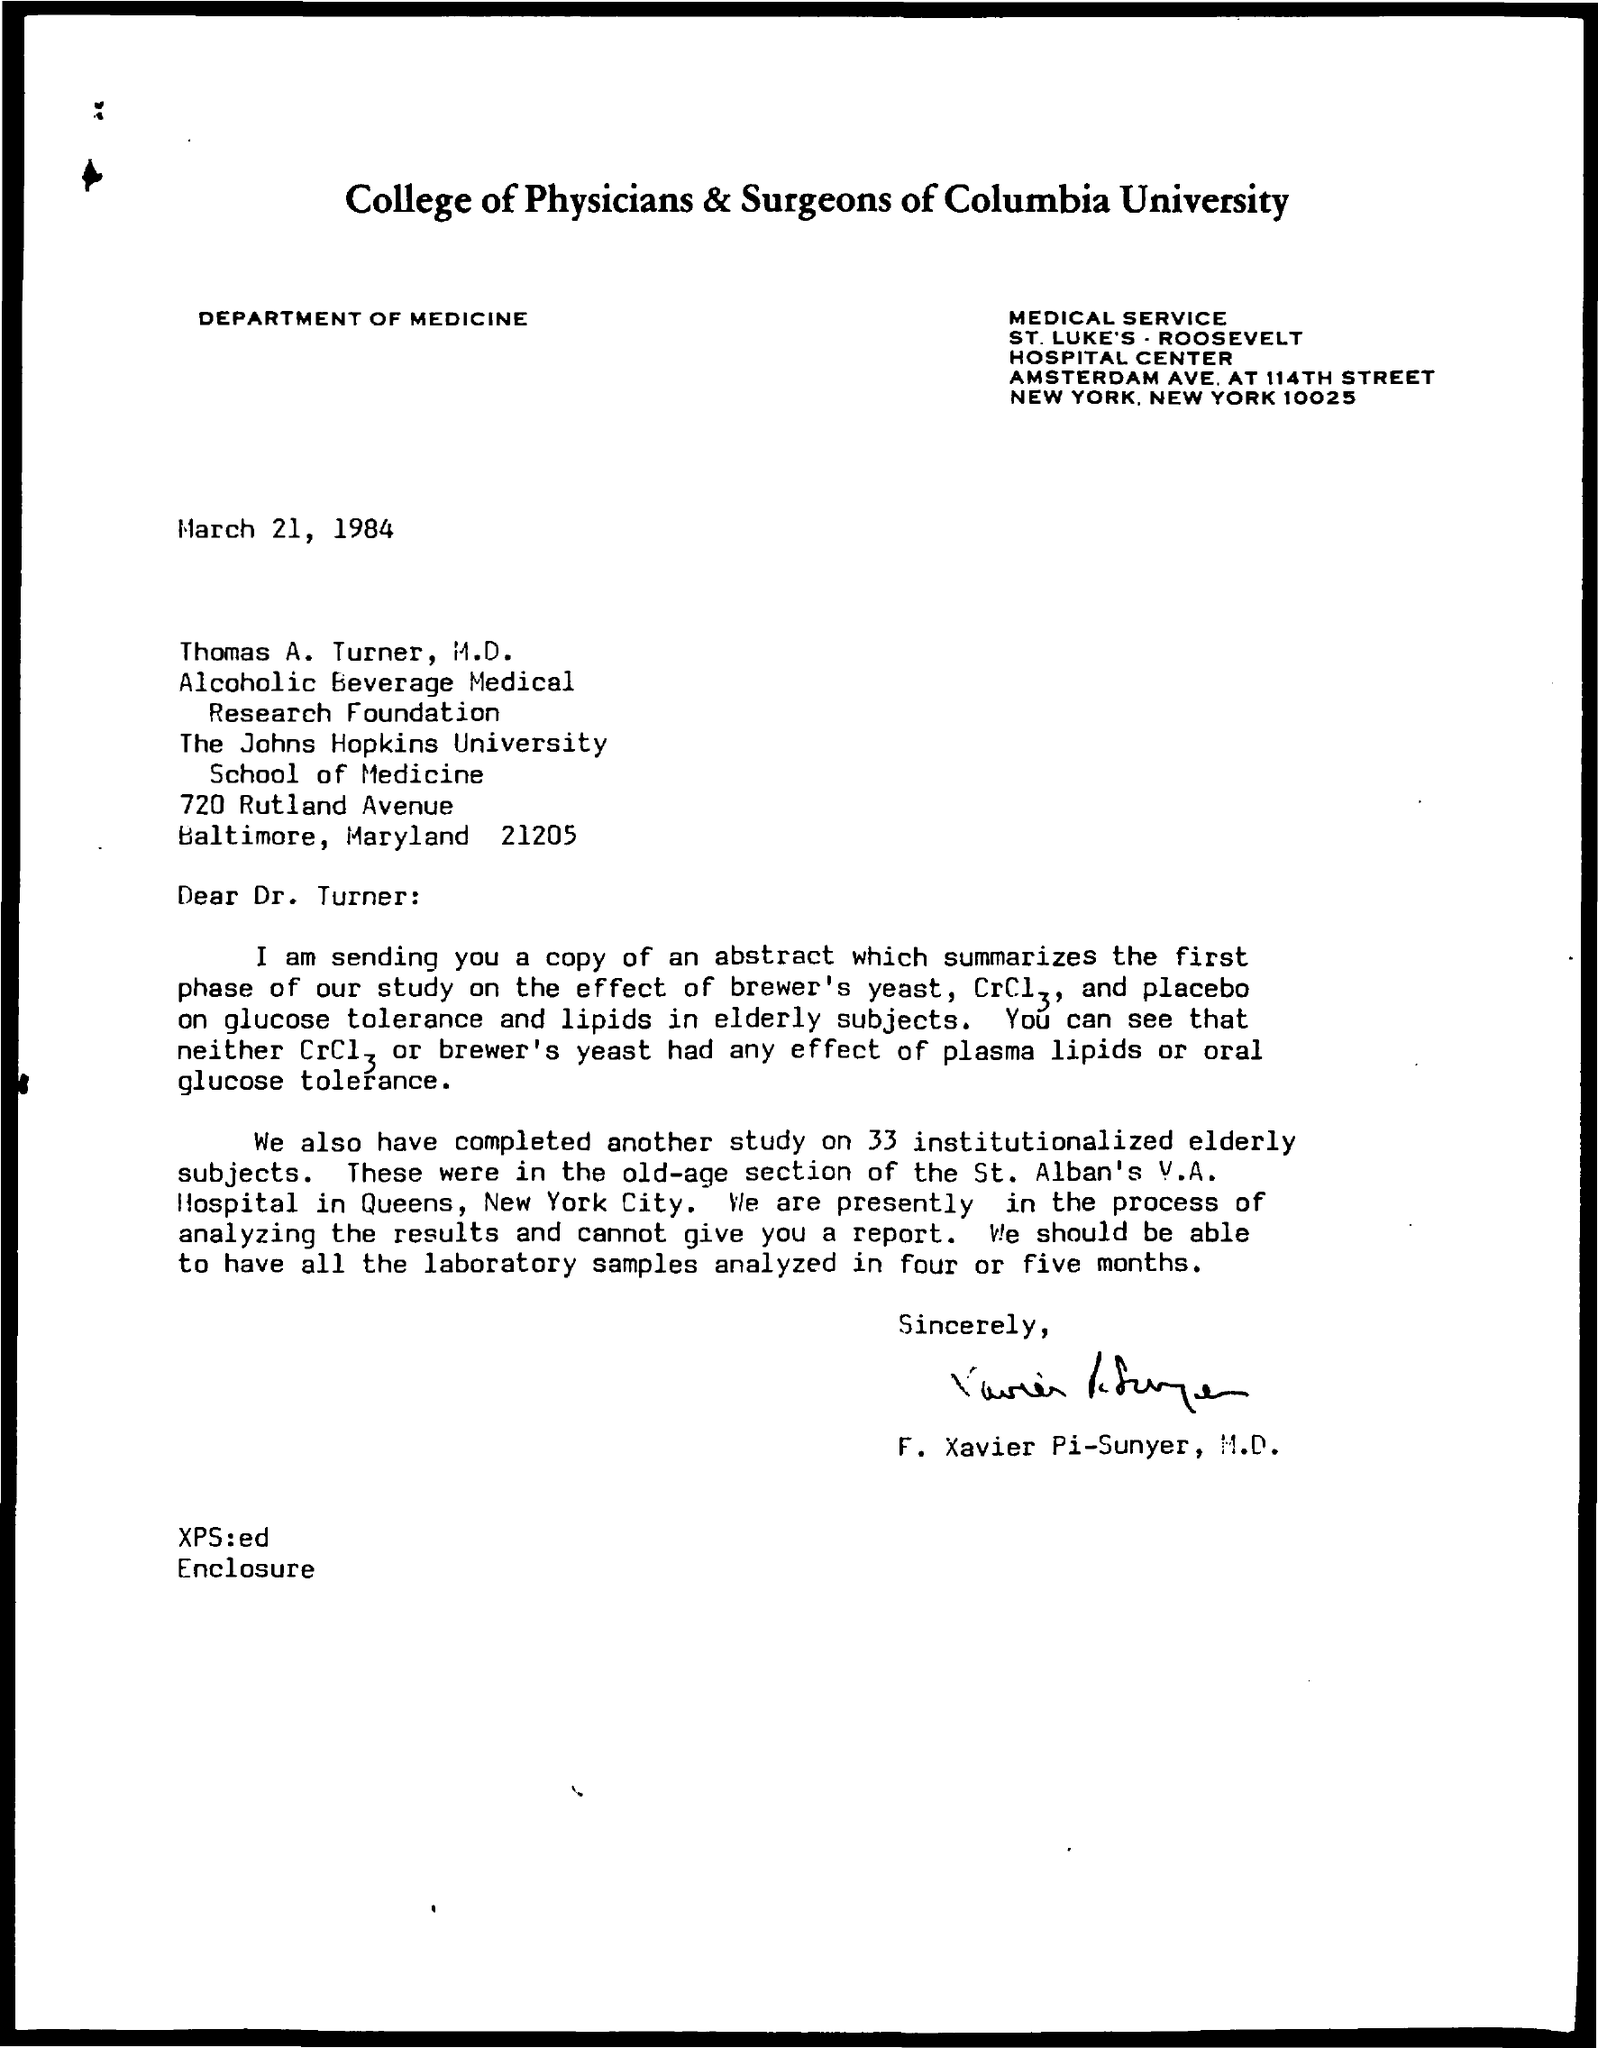Which college is mentioned in the document?
Provide a short and direct response. College of physicians & surgeons of columbia university. Which department is mentioned in the document?
Provide a short and direct response. Department of Medicine. 